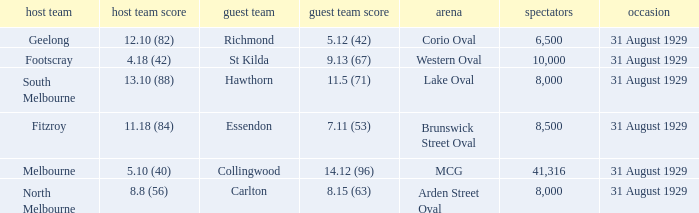What is the largest crowd when the away team is Hawthorn? 8000.0. 